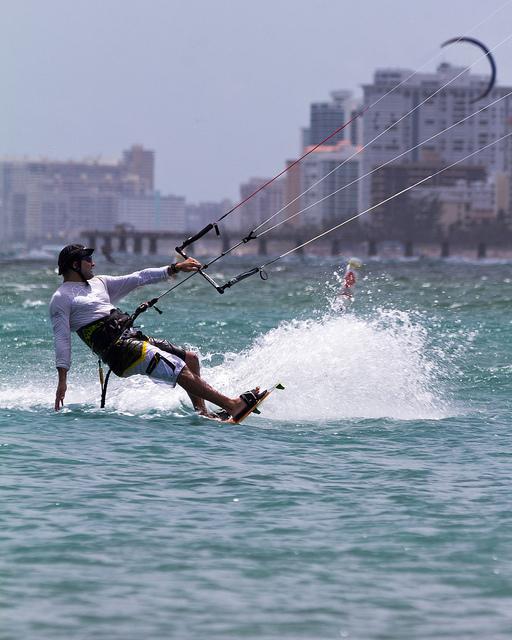How many strings is attached to the handle?
Concise answer only. 4. Is this person touching the water with their hand?
Short answer required. Yes. What colors are on the clothes this person is wearing?
Write a very short answer. White. 